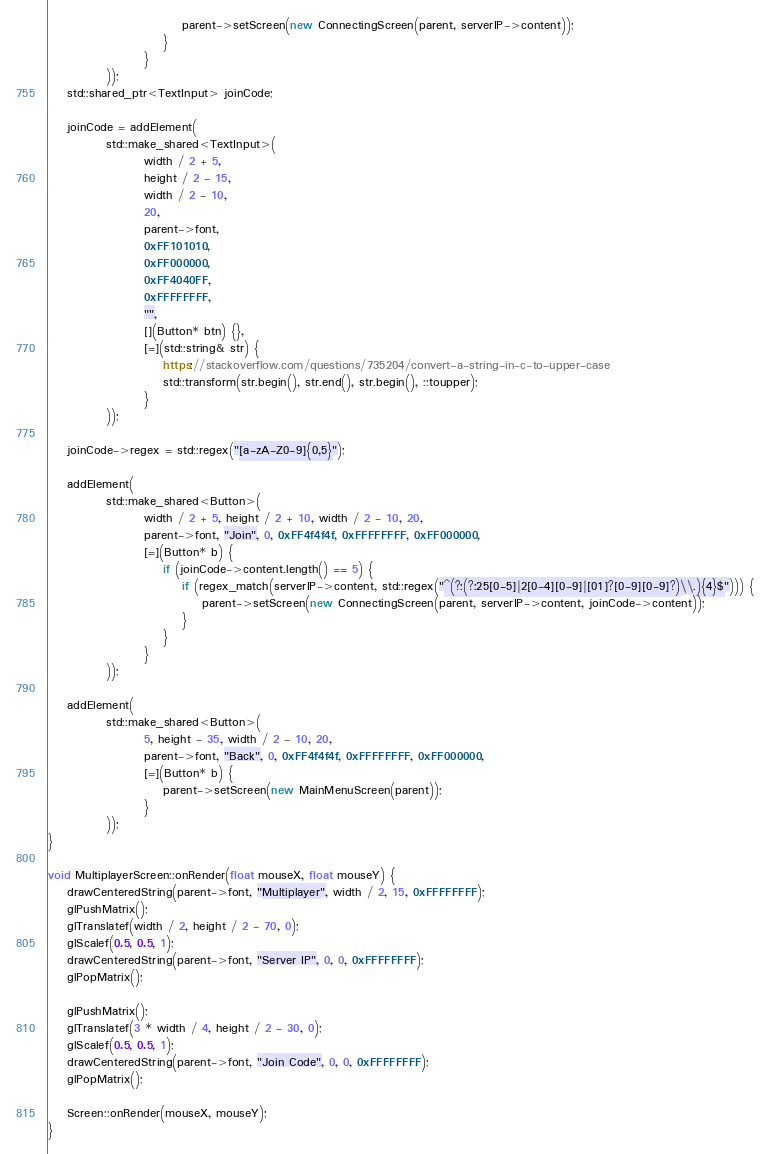Convert code to text. <code><loc_0><loc_0><loc_500><loc_500><_C++_>                            parent->setScreen(new ConnectingScreen(parent, serverIP->content));
                        }
                    }
            ));
    std::shared_ptr<TextInput> joinCode;

    joinCode = addElement(
            std::make_shared<TextInput>(
                    width / 2 + 5,
                    height / 2 - 15,
                    width / 2 - 10,
                    20,
                    parent->font,
                    0xFF101010,
                    0xFF000000,
                    0xFF4040FF,
                    0xFFFFFFFF,
                    "",
                    [](Button* btn) {},
                    [=](std::string& str) {
                        https://stackoverflow.com/questions/735204/convert-a-string-in-c-to-upper-case
                        std::transform(str.begin(), str.end(), str.begin(), ::toupper);
                    }
            ));

    joinCode->regex = std::regex("[a-zA-Z0-9]{0,5}");

    addElement(
            std::make_shared<Button>(
                    width / 2 + 5, height / 2 + 10, width / 2 - 10, 20,
                    parent->font, "Join", 0, 0xFF4f4f4f, 0xFFFFFFFF, 0xFF000000,
                    [=](Button* b) {
                        if (joinCode->content.length() == 5) {
                            if (regex_match(serverIP->content, std::regex("^(?:(?:25[0-5]|2[0-4][0-9]|[01]?[0-9][0-9]?)\\.){4}$"))) {
                                parent->setScreen(new ConnectingScreen(parent, serverIP->content, joinCode->content));
                            }
                        }
                    }
            ));

    addElement(
            std::make_shared<Button>(
                    5, height - 35, width / 2 - 10, 20,
                    parent->font, "Back", 0, 0xFF4f4f4f, 0xFFFFFFFF, 0xFF000000,
                    [=](Button* b) {
                        parent->setScreen(new MainMenuScreen(parent));
                    }
            ));
}

void MultiplayerScreen::onRender(float mouseX, float mouseY) {
    drawCenteredString(parent->font, "Multiplayer", width / 2, 15, 0xFFFFFFFF);
    glPushMatrix();
    glTranslatef(width / 2, height / 2 - 70, 0);
    glScalef(0.5, 0.5, 1);
    drawCenteredString(parent->font, "Server IP", 0, 0, 0xFFFFFFFF);
    glPopMatrix();

    glPushMatrix();
    glTranslatef(3 * width / 4, height / 2 - 30, 0);
    glScalef(0.5, 0.5, 1);
    drawCenteredString(parent->font, "Join Code", 0, 0, 0xFFFFFFFF);
    glPopMatrix();

    Screen::onRender(mouseX, mouseY);
}
</code> 